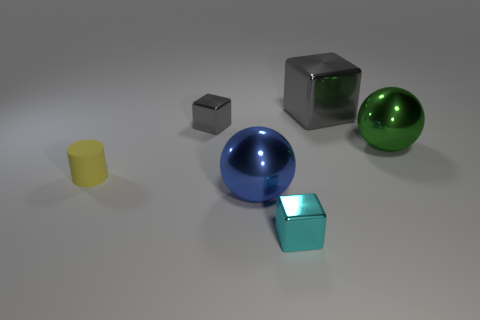Subtract 1 blocks. How many blocks are left? 2 Add 3 small matte cylinders. How many objects exist? 9 Subtract all tiny cubes. How many cubes are left? 1 Subtract all spheres. How many objects are left? 4 Add 3 gray shiny cubes. How many gray shiny cubes exist? 5 Subtract 0 brown cylinders. How many objects are left? 6 Subtract all yellow matte things. Subtract all tiny gray blocks. How many objects are left? 4 Add 3 big metal blocks. How many big metal blocks are left? 4 